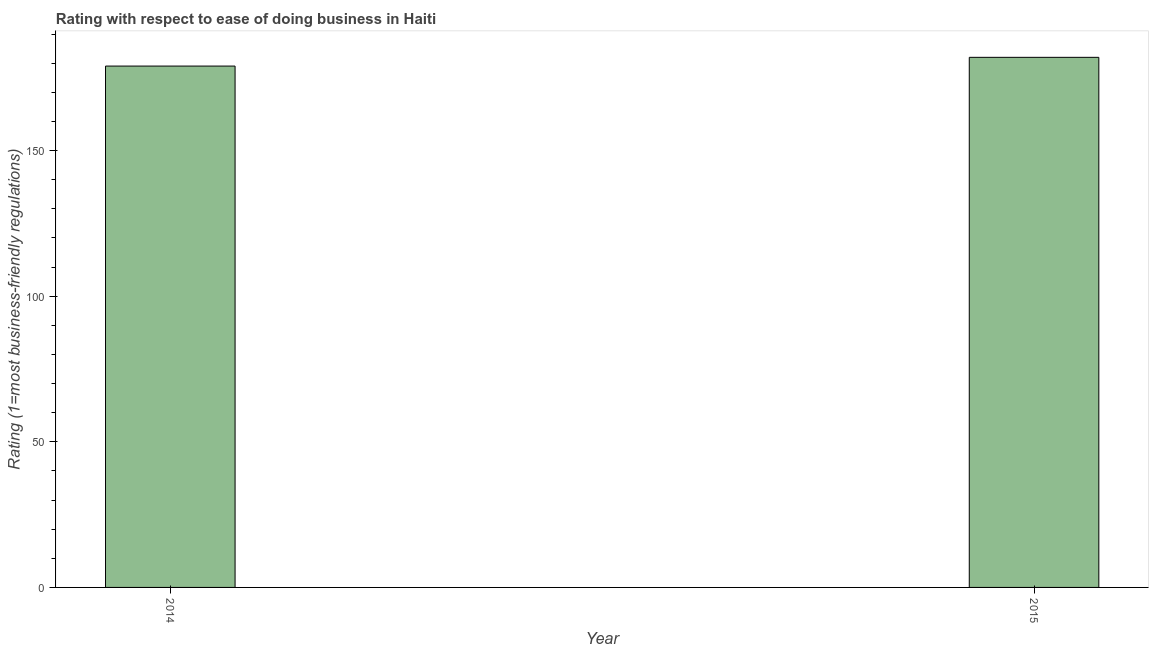Does the graph contain any zero values?
Give a very brief answer. No. What is the title of the graph?
Provide a succinct answer. Rating with respect to ease of doing business in Haiti. What is the label or title of the Y-axis?
Offer a very short reply. Rating (1=most business-friendly regulations). What is the ease of doing business index in 2014?
Give a very brief answer. 179. Across all years, what is the maximum ease of doing business index?
Your answer should be compact. 182. Across all years, what is the minimum ease of doing business index?
Keep it short and to the point. 179. In which year was the ease of doing business index maximum?
Your response must be concise. 2015. What is the sum of the ease of doing business index?
Your answer should be very brief. 361. What is the difference between the ease of doing business index in 2014 and 2015?
Provide a succinct answer. -3. What is the average ease of doing business index per year?
Provide a short and direct response. 180. What is the median ease of doing business index?
Your response must be concise. 180.5. In how many years, is the ease of doing business index greater than 20 ?
Make the answer very short. 2. Do a majority of the years between 2015 and 2014 (inclusive) have ease of doing business index greater than 90 ?
Give a very brief answer. No. What is the ratio of the ease of doing business index in 2014 to that in 2015?
Offer a terse response. 0.98. Is the ease of doing business index in 2014 less than that in 2015?
Provide a succinct answer. Yes. Are all the bars in the graph horizontal?
Make the answer very short. No. What is the difference between two consecutive major ticks on the Y-axis?
Offer a terse response. 50. What is the Rating (1=most business-friendly regulations) in 2014?
Provide a short and direct response. 179. What is the Rating (1=most business-friendly regulations) of 2015?
Provide a short and direct response. 182. What is the difference between the Rating (1=most business-friendly regulations) in 2014 and 2015?
Give a very brief answer. -3. 